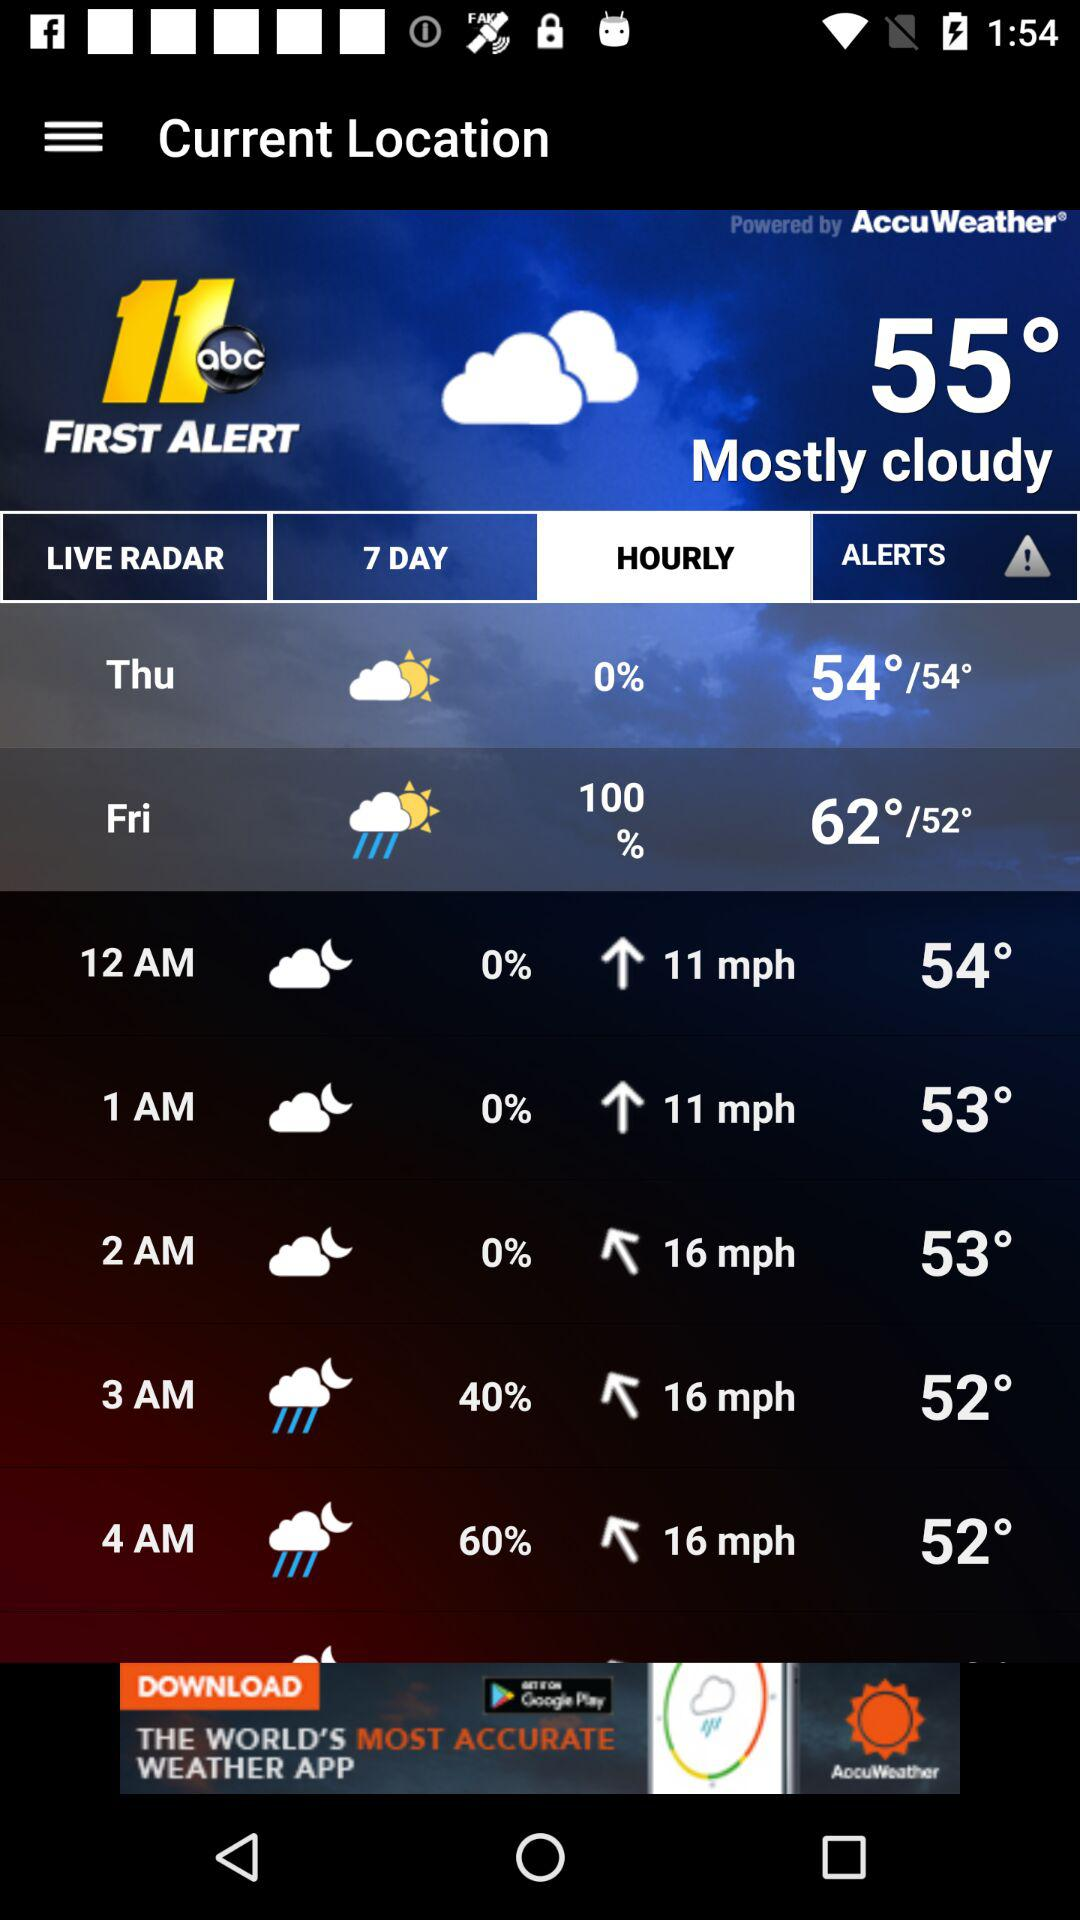What is the temperature for Friday?
Answer the question using a single word or phrase. 62°/52° 